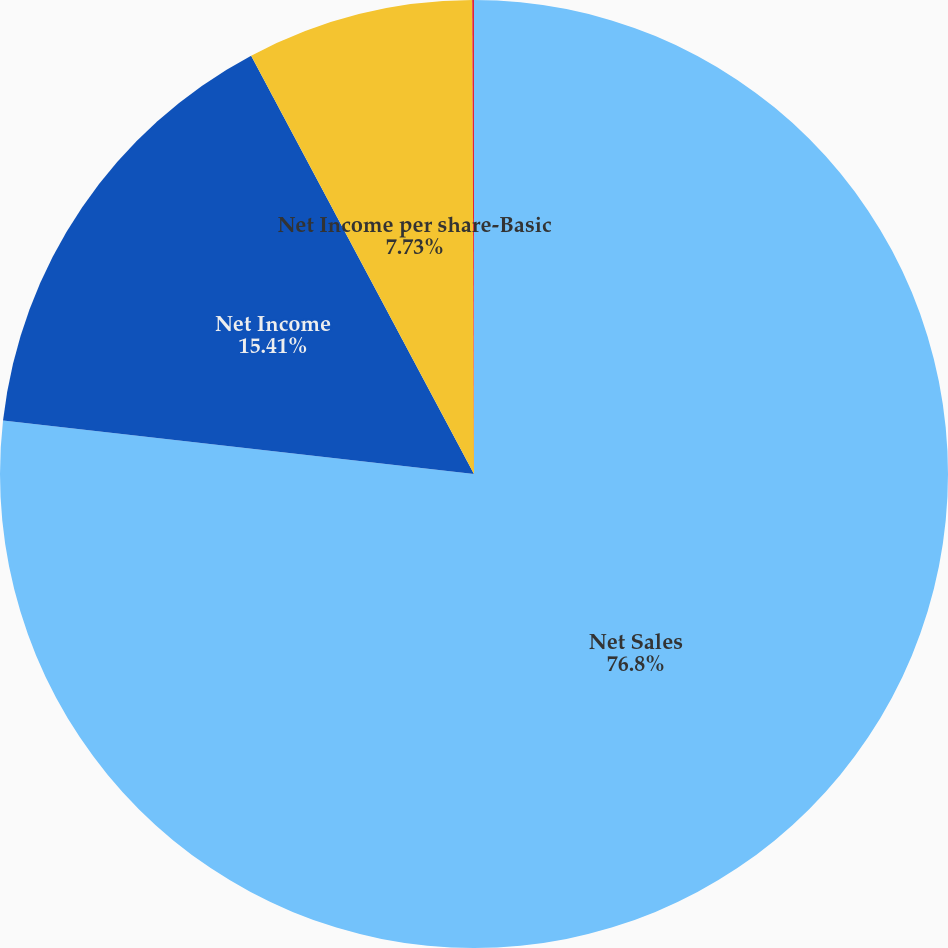Convert chart. <chart><loc_0><loc_0><loc_500><loc_500><pie_chart><fcel>Net Sales<fcel>Net Income<fcel>Net Income per share-Basic<fcel>Net Income per share-Diluted<nl><fcel>76.8%<fcel>15.41%<fcel>7.73%<fcel>0.06%<nl></chart> 